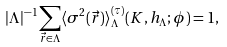Convert formula to latex. <formula><loc_0><loc_0><loc_500><loc_500>| \Lambda | ^ { - 1 } \sum _ { \vec { r } \in \Lambda } \langle \sigma ^ { 2 } ( \vec { r } ) \rangle _ { \Lambda } ^ { ( \tau ) } ( K , h _ { \Lambda } ; \phi ) = 1 ,</formula> 